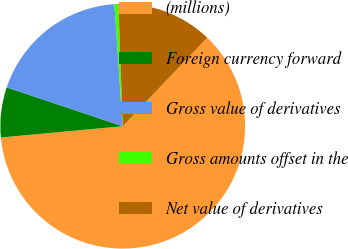Convert chart to OTSL. <chart><loc_0><loc_0><loc_500><loc_500><pie_chart><fcel>(millions)<fcel>Foreign currency forward<fcel>Gross value of derivatives<fcel>Gross amounts offset in the<fcel>Net value of derivatives<nl><fcel>61.4%<fcel>6.61%<fcel>18.78%<fcel>0.52%<fcel>12.69%<nl></chart> 